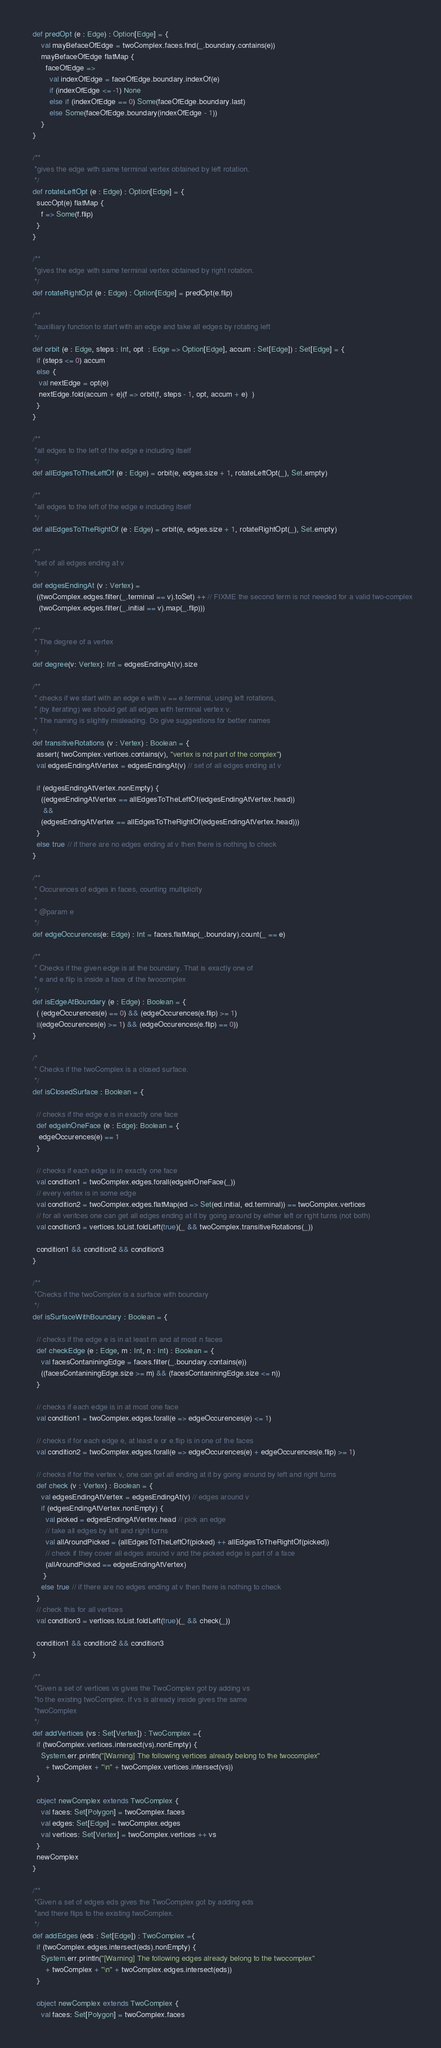Convert code to text. <code><loc_0><loc_0><loc_500><loc_500><_Scala_>  def predOpt (e : Edge) : Option[Edge] = {
      val mayBefaceOfEdge = twoComplex.faces.find(_.boundary.contains(e))
      mayBefaceOfEdge flatMap {
        faceOfEdge => 
          val indexOfEdge = faceOfEdge.boundary.indexOf(e)
          if (indexOfEdge <= -1) None
          else if (indexOfEdge == 0) Some(faceOfEdge.boundary.last)
          else Some(faceOfEdge.boundary(indexOfEdge - 1))
      }
  }        

  /** 
   *gives the edge with same terminal vertex obtained by left rotation.
   */
  def rotateLeftOpt (e : Edge) : Option[Edge] = {
    succOpt(e) flatMap {
      f => Some(f.flip)
    }
  }

  /** 
   *gives the edge with same terminal vertex obtained by right rotation.
   */
  def rotateRightOpt (e : Edge) : Option[Edge] = predOpt(e.flip)
  
  /** 
   *auxilliary function to start with an edge and take all edges by rotating left 
   */
  def orbit (e : Edge, steps : Int, opt  : Edge => Option[Edge], accum : Set[Edge]) : Set[Edge] = {
    if (steps <= 0) accum
    else { 
     val nextEdge = opt(e)
     nextEdge.fold(accum + e)(f => orbit(f, steps - 1, opt, accum + e)  )
    }
  } 

  /**
   *all edges to the left of the edge e including itself
   */  
  def allEdgesToTheLeftOf (e : Edge) = orbit(e, edges.size + 1, rotateLeftOpt(_), Set.empty)
  
  /** 
   *all edges to the left of the edge e including itself
   */
  def allEdgesToTheRightOf (e : Edge) = orbit(e, edges.size + 1, rotateRightOpt(_), Set.empty)
  
  /** 
   *set of all edges ending at v 
   */
  def edgesEndingAt (v : Vertex) = 
    ((twoComplex.edges.filter(_.terminal == v).toSet) ++ // FIXME the second term is not needed for a valid two-complex
     (twoComplex.edges.filter(_.initial == v).map(_.flip)))

  /**
   * The degree of a vertex
   */
  def degree(v: Vertex): Int = edgesEndingAt(v).size

  /** 
   * checks if we start with an edge e with v == e.terminal, using left rotations, 
   * (by iterating) we should get all edges with terminal vertex v.
   * The naming is slightly misleading. Do give suggestions for better names
  */
  def transitiveRotations (v : Vertex) : Boolean = {
    assert( twoComplex.vertices.contains(v), "vertex is not part of the complex")
    val edgesEndingAtVertex = edgesEndingAt(v) // set of all edges ending at v
  
    if (edgesEndingAtVertex.nonEmpty) {
      ((edgesEndingAtVertex == allEdgesToTheLeftOf(edgesEndingAtVertex.head)) 
       && 
      (edgesEndingAtVertex == allEdgesToTheRightOf(edgesEndingAtVertex.head))) 
    }
    else true // if there are no edges ending at v then there is nothing to check
  }   
  
  /**
   * Occurences of edges in faces, counting multiplicity
   *
   * @param e
   */
  def edgeOccurences(e: Edge) : Int = faces.flatMap(_.boundary).count(_ == e)

  /**
   * Checks if the given edge is at the boundary. That is exactly one of
   * e and e.flip is inside a face of the twocomplex
   */
  def isEdgeAtBoundary (e : Edge) : Boolean = {
    ( (edgeOccurences(e) == 0) && (edgeOccurences(e.flip) >= 1)
    ||(edgeOccurences(e) >= 1) && (edgeOccurences(e.flip) == 0))
  }

  /*
   * Checks if the twoComplex is a closed surface. 
   */
  def isClosedSurface : Boolean = {
    
    // checks if the edge e is in exactly one face
    def edgeInOneFace (e : Edge): Boolean = {
     edgeOccurences(e) == 1
    } 
    
    // checks if each edge is in exactly one face
    val condition1 = twoComplex.edges.forall(edgeInOneFace(_)) 
    // every vertex is in some edge
    val condition2 = twoComplex.edges.flatMap(ed => Set(ed.initial, ed.terminal)) == twoComplex.vertices
    // for all veritces one can get all edges ending at it by going around by either left or right turns (not both) 
    val condition3 = vertices.toList.foldLeft(true)(_ && twoComplex.transitiveRotations(_))

    condition1 && condition2 && condition3
  }

  /** 
   *Checks if the twoComplex is a surface with boundary
   */
  def isSurfaceWithBoundary : Boolean = {

    // checks if the edge e is in at least m and at most n faces
    def checkEdge (e : Edge, m : Int, n : Int) : Boolean = {
      val facesContaniningEdge = faces.filter(_.boundary.contains(e))
      ((facesContaniningEdge.size >= m) && (facesContaniningEdge.size <= n))
    }

    // checks if each edge is in at most one face
    val condition1 = twoComplex.edges.forall(e => edgeOccurences(e) <= 1)

    // checks if for each edge e, at least e or e.flip is in one of the faces
    val condition2 = twoComplex.edges.forall(e => edgeOccurences(e) + edgeOccurences(e.flip) >= 1)

    // checks if for the vertex v, one can get all ending at it by going around by left and right turns
    def check (v : Vertex) : Boolean = {
      val edgesEndingAtVertex = edgesEndingAt(v) // edges around v
      if (edgesEndingAtVertex.nonEmpty) {
        val picked = edgesEndingAtVertex.head // pick an edge
        // take all edges by left and right turns
        val allAroundPicked = (allEdgesToTheLeftOf(picked) ++ allEdgesToTheRightOf(picked)) 
        // check if they cover all edges around v and the picked edge is part of a face
        (allAroundPicked == edgesEndingAtVertex)       
       }
      else true // if there are no edges ending at v then there is nothing to check 
    } 
    // check this for all vertices
    val condition3 = vertices.toList.foldLeft(true)(_ && check(_))
    
    condition1 && condition2 && condition3
  }  

  /** 
   *Given a set of vertices vs gives the TwoComplex got by adding vs 
   *to the existing twoComplex. If vs is already inside gives the same 
   *twoComplex 
   */
  def addVertices (vs : Set[Vertex]) : TwoComplex ={
    if (twoComplex.vertices.intersect(vs).nonEmpty) {
      System.err.println("[Warning] The following vertices already belong to the twocomplex" 
        + twoComplex + "\n" + twoComplex.vertices.intersect(vs))
    }

    object newComplex extends TwoComplex {
      val faces: Set[Polygon] = twoComplex.faces
      val edges: Set[Edge] = twoComplex.edges
      val vertices: Set[Vertex] = twoComplex.vertices ++ vs
    }
    newComplex
  }
  
  /** 
   *Given a set of edges eds gives the TwoComplex got by adding eds 
   *and there flips to the existing twoComplex.
   */
  def addEdges (eds : Set[Edge]) : TwoComplex ={
    if (twoComplex.edges.intersect(eds).nonEmpty) {
      System.err.println("[Warning] The following edges already belong to the twocomplex" 
        + twoComplex + "\n" + twoComplex.edges.intersect(eds))
    }

    object newComplex extends TwoComplex {
      val faces: Set[Polygon] = twoComplex.faces</code> 